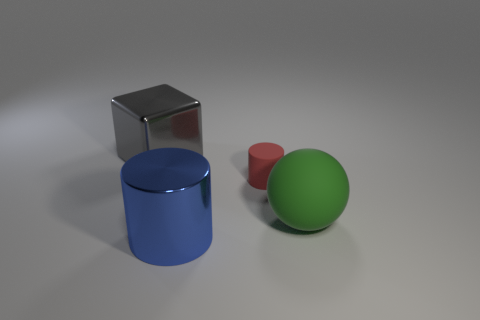How many blue cylinders are the same size as the blue shiny object? 0 